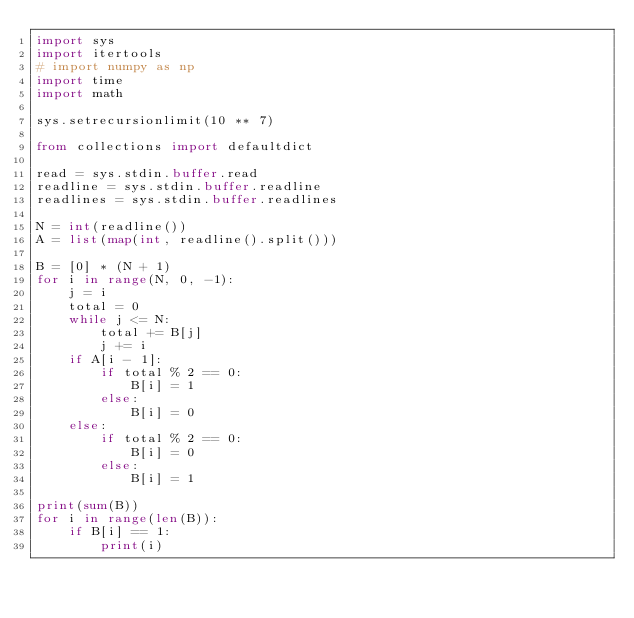<code> <loc_0><loc_0><loc_500><loc_500><_Python_>import sys
import itertools
# import numpy as np
import time
import math
 
sys.setrecursionlimit(10 ** 7)
 
from collections import defaultdict
 
read = sys.stdin.buffer.read
readline = sys.stdin.buffer.readline
readlines = sys.stdin.buffer.readlines

N = int(readline())
A = list(map(int, readline().split()))

B = [0] * (N + 1)
for i in range(N, 0, -1):
    j = i
    total = 0
    while j <= N:
        total += B[j]
        j += i
    if A[i - 1]:
        if total % 2 == 0:
            B[i] = 1
        else:
            B[i] = 0
    else:
        if total % 2 == 0:
            B[i] = 0
        else:
            B[i] = 1

print(sum(B))
for i in range(len(B)):
    if B[i] == 1:
        print(i)</code> 